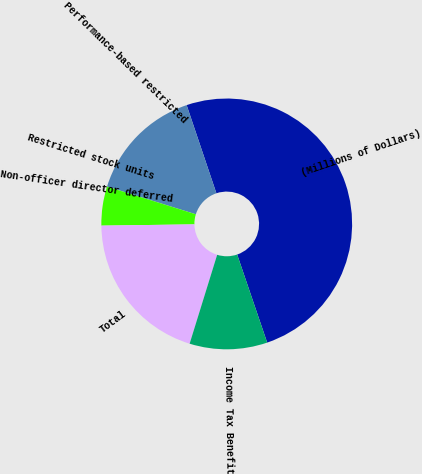Convert chart. <chart><loc_0><loc_0><loc_500><loc_500><pie_chart><fcel>(Millions of Dollars)<fcel>Performance-based restricted<fcel>Restricted stock units<fcel>Non-officer director deferred<fcel>Total<fcel>Income Tax Benefit<nl><fcel>49.95%<fcel>15.0%<fcel>0.02%<fcel>5.02%<fcel>20.0%<fcel>10.01%<nl></chart> 